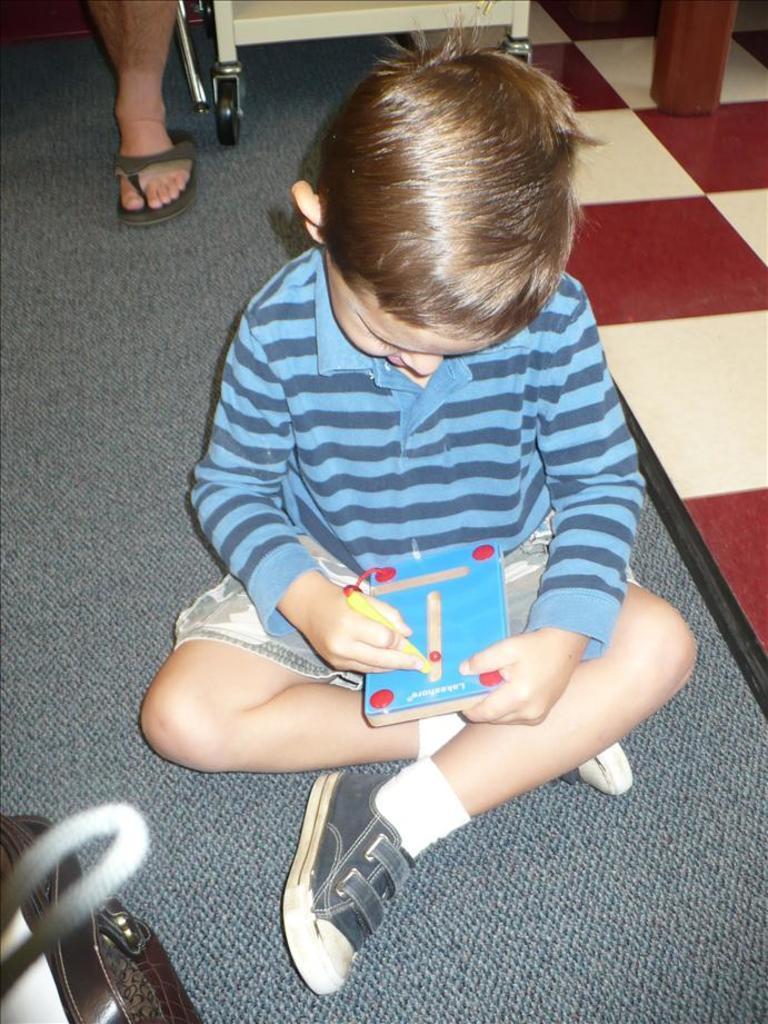Could you give a brief overview of what you see in this image? In this image, there is a boy sitting and he is holding a book, at the background there is a leg of a person and there is a floor. 